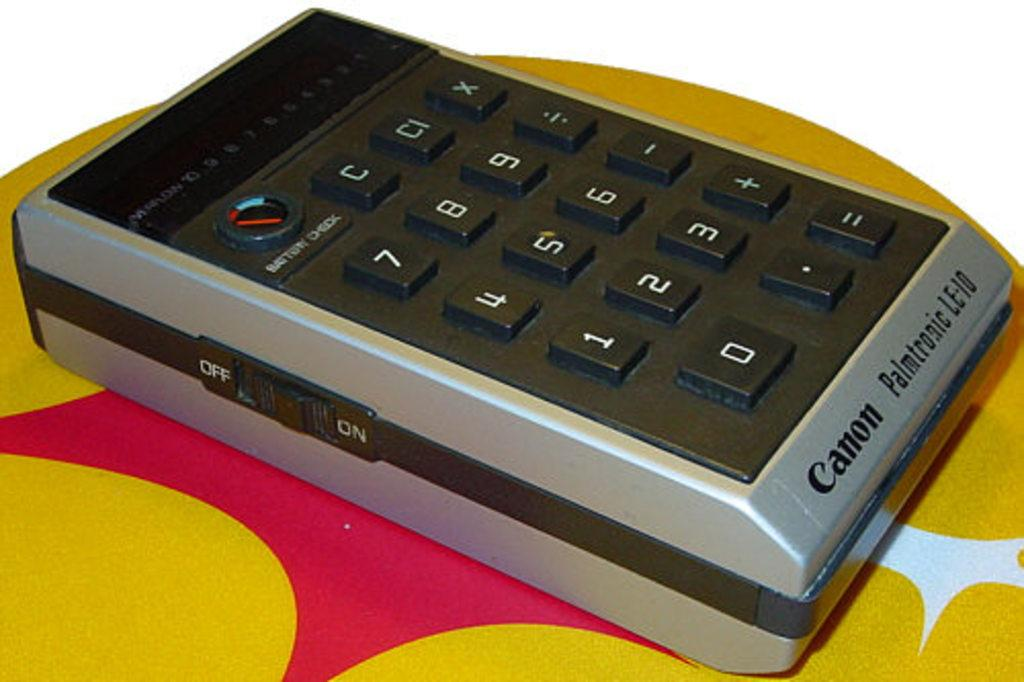<image>
Present a compact description of the photo's key features. A very large calculator sits on a yellow and pink table with the word Canon written on the bottom of it. 